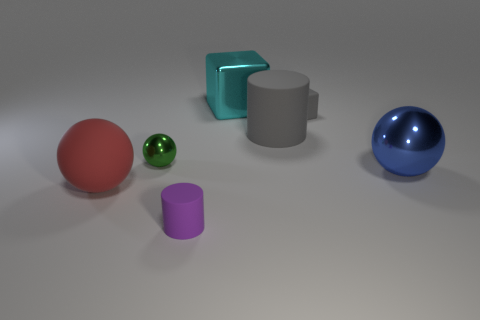Add 2 balls. How many objects exist? 9 Subtract all blocks. How many objects are left? 5 Subtract all blue blocks. Subtract all shiny objects. How many objects are left? 4 Add 3 tiny matte things. How many tiny matte things are left? 5 Add 1 large gray cylinders. How many large gray cylinders exist? 2 Subtract 0 red cubes. How many objects are left? 7 